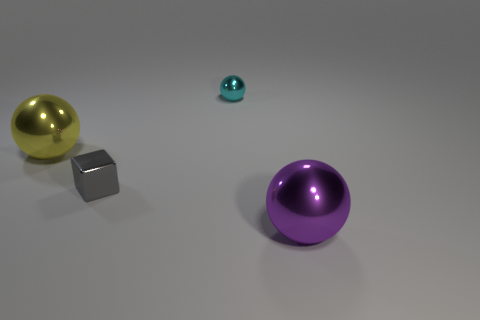Add 4 gray blocks. How many objects exist? 8 Subtract all spheres. How many objects are left? 1 Subtract all matte balls. Subtract all large spheres. How many objects are left? 2 Add 4 spheres. How many spheres are left? 7 Add 1 big yellow balls. How many big yellow balls exist? 2 Subtract 0 yellow cubes. How many objects are left? 4 